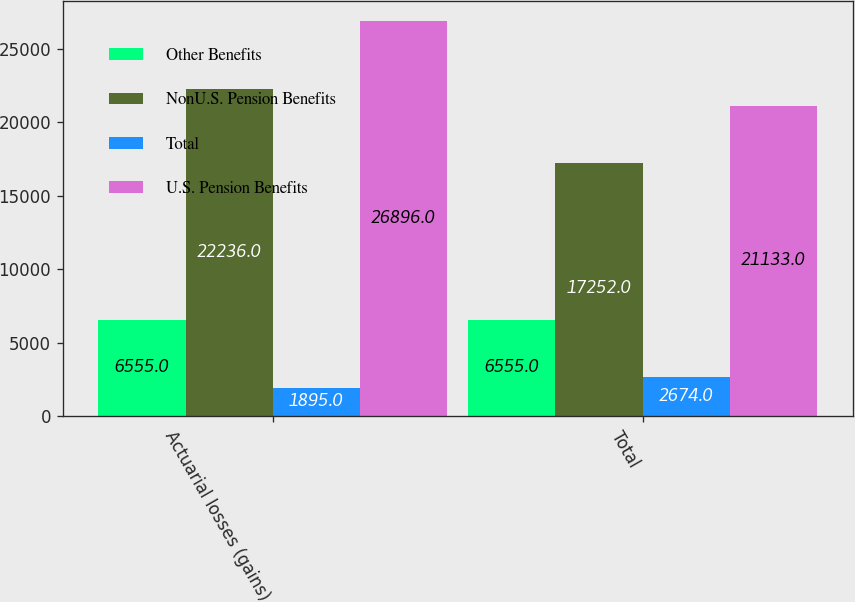Convert chart to OTSL. <chart><loc_0><loc_0><loc_500><loc_500><stacked_bar_chart><ecel><fcel>Actuarial losses (gains)<fcel>Total<nl><fcel>Other Benefits<fcel>6555<fcel>6555<nl><fcel>NonU.S. Pension Benefits<fcel>22236<fcel>17252<nl><fcel>Total<fcel>1895<fcel>2674<nl><fcel>U.S. Pension Benefits<fcel>26896<fcel>21133<nl></chart> 